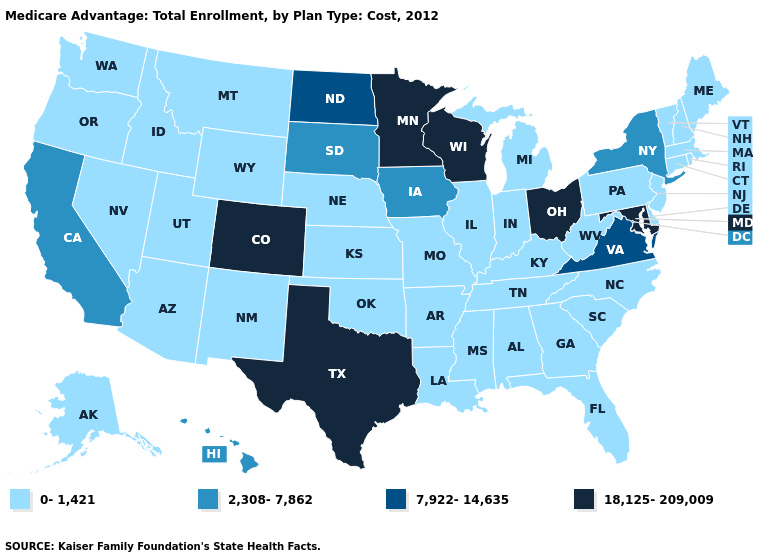Name the states that have a value in the range 2,308-7,862?
Be succinct. California, Hawaii, Iowa, New York, South Dakota. Name the states that have a value in the range 0-1,421?
Give a very brief answer. Alaska, Alabama, Arkansas, Arizona, Connecticut, Delaware, Florida, Georgia, Idaho, Illinois, Indiana, Kansas, Kentucky, Louisiana, Massachusetts, Maine, Michigan, Missouri, Mississippi, Montana, North Carolina, Nebraska, New Hampshire, New Jersey, New Mexico, Nevada, Oklahoma, Oregon, Pennsylvania, Rhode Island, South Carolina, Tennessee, Utah, Vermont, Washington, West Virginia, Wyoming. Does Hawaii have the lowest value in the West?
Write a very short answer. No. Name the states that have a value in the range 18,125-209,009?
Answer briefly. Colorado, Maryland, Minnesota, Ohio, Texas, Wisconsin. Name the states that have a value in the range 7,922-14,635?
Short answer required. North Dakota, Virginia. What is the value of Vermont?
Short answer required. 0-1,421. Which states have the lowest value in the South?
Write a very short answer. Alabama, Arkansas, Delaware, Florida, Georgia, Kentucky, Louisiana, Mississippi, North Carolina, Oklahoma, South Carolina, Tennessee, West Virginia. What is the value of Utah?
Short answer required. 0-1,421. Which states hav the highest value in the MidWest?
Write a very short answer. Minnesota, Ohio, Wisconsin. What is the value of Wyoming?
Be succinct. 0-1,421. What is the value of Kansas?
Short answer required. 0-1,421. Among the states that border Wyoming , does Colorado have the highest value?
Short answer required. Yes. Among the states that border Colorado , which have the highest value?
Keep it brief. Arizona, Kansas, Nebraska, New Mexico, Oklahoma, Utah, Wyoming. Does Alabama have the lowest value in the USA?
Short answer required. Yes. Name the states that have a value in the range 7,922-14,635?
Quick response, please. North Dakota, Virginia. 